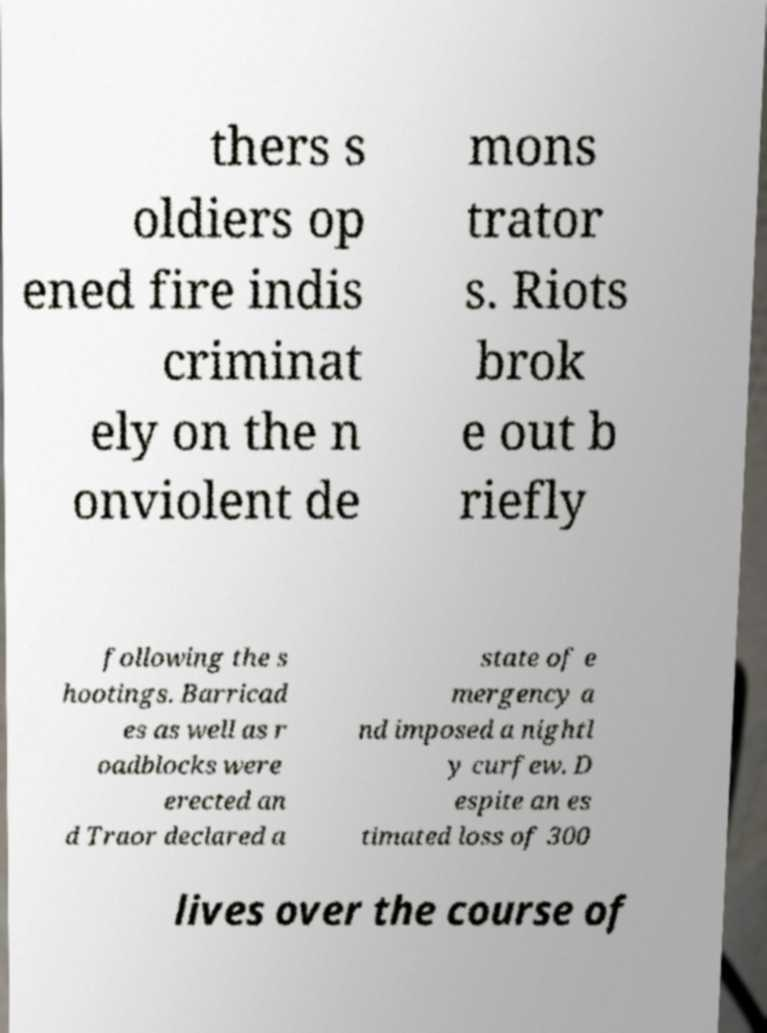Please read and relay the text visible in this image. What does it say? thers s oldiers op ened fire indis criminat ely on the n onviolent de mons trator s. Riots brok e out b riefly following the s hootings. Barricad es as well as r oadblocks were erected an d Traor declared a state of e mergency a nd imposed a nightl y curfew. D espite an es timated loss of 300 lives over the course of 